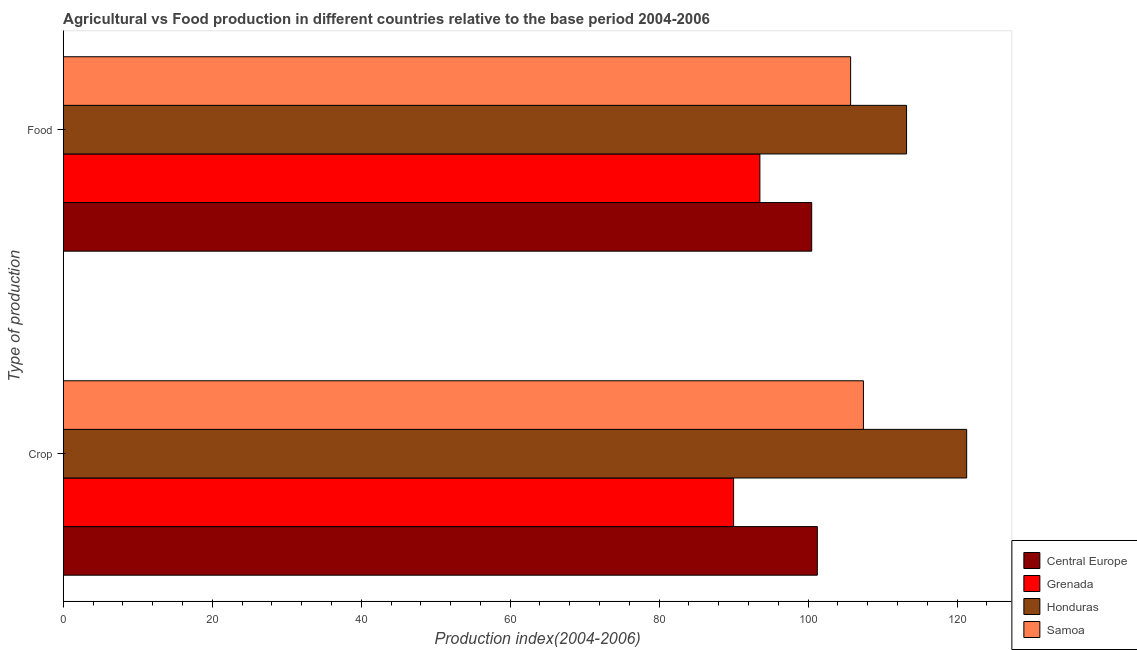How many different coloured bars are there?
Provide a succinct answer. 4. How many groups of bars are there?
Your response must be concise. 2. Are the number of bars per tick equal to the number of legend labels?
Provide a succinct answer. Yes. Are the number of bars on each tick of the Y-axis equal?
Provide a succinct answer. Yes. How many bars are there on the 1st tick from the bottom?
Your answer should be very brief. 4. What is the label of the 2nd group of bars from the top?
Your answer should be compact. Crop. What is the crop production index in Samoa?
Offer a terse response. 107.42. Across all countries, what is the maximum food production index?
Ensure brevity in your answer.  113.21. Across all countries, what is the minimum food production index?
Ensure brevity in your answer.  93.52. In which country was the crop production index maximum?
Make the answer very short. Honduras. In which country was the crop production index minimum?
Give a very brief answer. Grenada. What is the total crop production index in the graph?
Ensure brevity in your answer.  419.92. What is the difference between the crop production index in Honduras and that in Samoa?
Offer a terse response. 13.86. What is the difference between the crop production index in Honduras and the food production index in Central Europe?
Keep it short and to the point. 20.8. What is the average crop production index per country?
Offer a very short reply. 104.98. What is the difference between the crop production index and food production index in Samoa?
Give a very brief answer. 1.72. What is the ratio of the crop production index in Grenada to that in Central Europe?
Offer a very short reply. 0.89. Is the food production index in Grenada less than that in Honduras?
Keep it short and to the point. Yes. What does the 2nd bar from the top in Food represents?
Provide a short and direct response. Honduras. What does the 4th bar from the bottom in Food represents?
Provide a short and direct response. Samoa. Does the graph contain any zero values?
Keep it short and to the point. No. Does the graph contain grids?
Ensure brevity in your answer.  No. Where does the legend appear in the graph?
Your response must be concise. Bottom right. How many legend labels are there?
Provide a succinct answer. 4. How are the legend labels stacked?
Your answer should be compact. Vertical. What is the title of the graph?
Keep it short and to the point. Agricultural vs Food production in different countries relative to the base period 2004-2006. Does "China" appear as one of the legend labels in the graph?
Your answer should be very brief. No. What is the label or title of the X-axis?
Provide a short and direct response. Production index(2004-2006). What is the label or title of the Y-axis?
Ensure brevity in your answer.  Type of production. What is the Production index(2004-2006) in Central Europe in Crop?
Your response must be concise. 101.23. What is the Production index(2004-2006) in Grenada in Crop?
Make the answer very short. 89.99. What is the Production index(2004-2006) in Honduras in Crop?
Your answer should be very brief. 121.28. What is the Production index(2004-2006) in Samoa in Crop?
Your response must be concise. 107.42. What is the Production index(2004-2006) in Central Europe in Food?
Ensure brevity in your answer.  100.48. What is the Production index(2004-2006) in Grenada in Food?
Provide a short and direct response. 93.52. What is the Production index(2004-2006) in Honduras in Food?
Your response must be concise. 113.21. What is the Production index(2004-2006) in Samoa in Food?
Keep it short and to the point. 105.7. Across all Type of production, what is the maximum Production index(2004-2006) in Central Europe?
Give a very brief answer. 101.23. Across all Type of production, what is the maximum Production index(2004-2006) in Grenada?
Give a very brief answer. 93.52. Across all Type of production, what is the maximum Production index(2004-2006) of Honduras?
Offer a very short reply. 121.28. Across all Type of production, what is the maximum Production index(2004-2006) in Samoa?
Offer a very short reply. 107.42. Across all Type of production, what is the minimum Production index(2004-2006) of Central Europe?
Your answer should be compact. 100.48. Across all Type of production, what is the minimum Production index(2004-2006) in Grenada?
Make the answer very short. 89.99. Across all Type of production, what is the minimum Production index(2004-2006) in Honduras?
Offer a terse response. 113.21. Across all Type of production, what is the minimum Production index(2004-2006) in Samoa?
Offer a very short reply. 105.7. What is the total Production index(2004-2006) of Central Europe in the graph?
Provide a short and direct response. 201.71. What is the total Production index(2004-2006) in Grenada in the graph?
Your answer should be compact. 183.51. What is the total Production index(2004-2006) in Honduras in the graph?
Offer a very short reply. 234.49. What is the total Production index(2004-2006) in Samoa in the graph?
Your answer should be compact. 213.12. What is the difference between the Production index(2004-2006) of Central Europe in Crop and that in Food?
Provide a short and direct response. 0.76. What is the difference between the Production index(2004-2006) in Grenada in Crop and that in Food?
Give a very brief answer. -3.53. What is the difference between the Production index(2004-2006) in Honduras in Crop and that in Food?
Your answer should be compact. 8.07. What is the difference between the Production index(2004-2006) in Samoa in Crop and that in Food?
Offer a very short reply. 1.72. What is the difference between the Production index(2004-2006) of Central Europe in Crop and the Production index(2004-2006) of Grenada in Food?
Offer a terse response. 7.71. What is the difference between the Production index(2004-2006) in Central Europe in Crop and the Production index(2004-2006) in Honduras in Food?
Keep it short and to the point. -11.98. What is the difference between the Production index(2004-2006) in Central Europe in Crop and the Production index(2004-2006) in Samoa in Food?
Make the answer very short. -4.47. What is the difference between the Production index(2004-2006) in Grenada in Crop and the Production index(2004-2006) in Honduras in Food?
Ensure brevity in your answer.  -23.22. What is the difference between the Production index(2004-2006) in Grenada in Crop and the Production index(2004-2006) in Samoa in Food?
Provide a succinct answer. -15.71. What is the difference between the Production index(2004-2006) in Honduras in Crop and the Production index(2004-2006) in Samoa in Food?
Provide a succinct answer. 15.58. What is the average Production index(2004-2006) in Central Europe per Type of production?
Your answer should be compact. 100.85. What is the average Production index(2004-2006) in Grenada per Type of production?
Your response must be concise. 91.75. What is the average Production index(2004-2006) in Honduras per Type of production?
Your answer should be very brief. 117.25. What is the average Production index(2004-2006) of Samoa per Type of production?
Keep it short and to the point. 106.56. What is the difference between the Production index(2004-2006) in Central Europe and Production index(2004-2006) in Grenada in Crop?
Provide a succinct answer. 11.24. What is the difference between the Production index(2004-2006) of Central Europe and Production index(2004-2006) of Honduras in Crop?
Your answer should be very brief. -20.05. What is the difference between the Production index(2004-2006) in Central Europe and Production index(2004-2006) in Samoa in Crop?
Your answer should be compact. -6.19. What is the difference between the Production index(2004-2006) of Grenada and Production index(2004-2006) of Honduras in Crop?
Your answer should be very brief. -31.29. What is the difference between the Production index(2004-2006) in Grenada and Production index(2004-2006) in Samoa in Crop?
Provide a succinct answer. -17.43. What is the difference between the Production index(2004-2006) of Honduras and Production index(2004-2006) of Samoa in Crop?
Provide a succinct answer. 13.86. What is the difference between the Production index(2004-2006) in Central Europe and Production index(2004-2006) in Grenada in Food?
Ensure brevity in your answer.  6.96. What is the difference between the Production index(2004-2006) of Central Europe and Production index(2004-2006) of Honduras in Food?
Give a very brief answer. -12.73. What is the difference between the Production index(2004-2006) of Central Europe and Production index(2004-2006) of Samoa in Food?
Your answer should be very brief. -5.22. What is the difference between the Production index(2004-2006) in Grenada and Production index(2004-2006) in Honduras in Food?
Provide a succinct answer. -19.69. What is the difference between the Production index(2004-2006) in Grenada and Production index(2004-2006) in Samoa in Food?
Your response must be concise. -12.18. What is the difference between the Production index(2004-2006) of Honduras and Production index(2004-2006) of Samoa in Food?
Offer a terse response. 7.51. What is the ratio of the Production index(2004-2006) of Central Europe in Crop to that in Food?
Give a very brief answer. 1.01. What is the ratio of the Production index(2004-2006) of Grenada in Crop to that in Food?
Your answer should be compact. 0.96. What is the ratio of the Production index(2004-2006) of Honduras in Crop to that in Food?
Provide a succinct answer. 1.07. What is the ratio of the Production index(2004-2006) in Samoa in Crop to that in Food?
Give a very brief answer. 1.02. What is the difference between the highest and the second highest Production index(2004-2006) of Central Europe?
Offer a very short reply. 0.76. What is the difference between the highest and the second highest Production index(2004-2006) of Grenada?
Offer a terse response. 3.53. What is the difference between the highest and the second highest Production index(2004-2006) in Honduras?
Make the answer very short. 8.07. What is the difference between the highest and the second highest Production index(2004-2006) of Samoa?
Provide a succinct answer. 1.72. What is the difference between the highest and the lowest Production index(2004-2006) in Central Europe?
Your answer should be very brief. 0.76. What is the difference between the highest and the lowest Production index(2004-2006) in Grenada?
Offer a terse response. 3.53. What is the difference between the highest and the lowest Production index(2004-2006) in Honduras?
Ensure brevity in your answer.  8.07. What is the difference between the highest and the lowest Production index(2004-2006) in Samoa?
Provide a short and direct response. 1.72. 